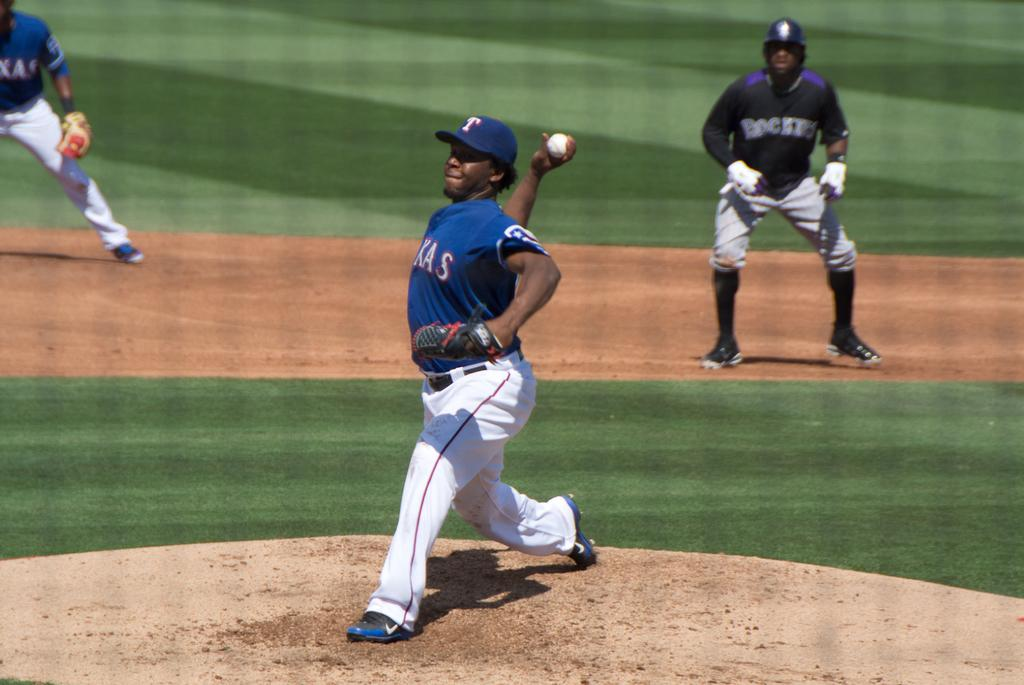Provide a one-sentence caption for the provided image. a baseball game going on, the pitcher has a T on his cap. 